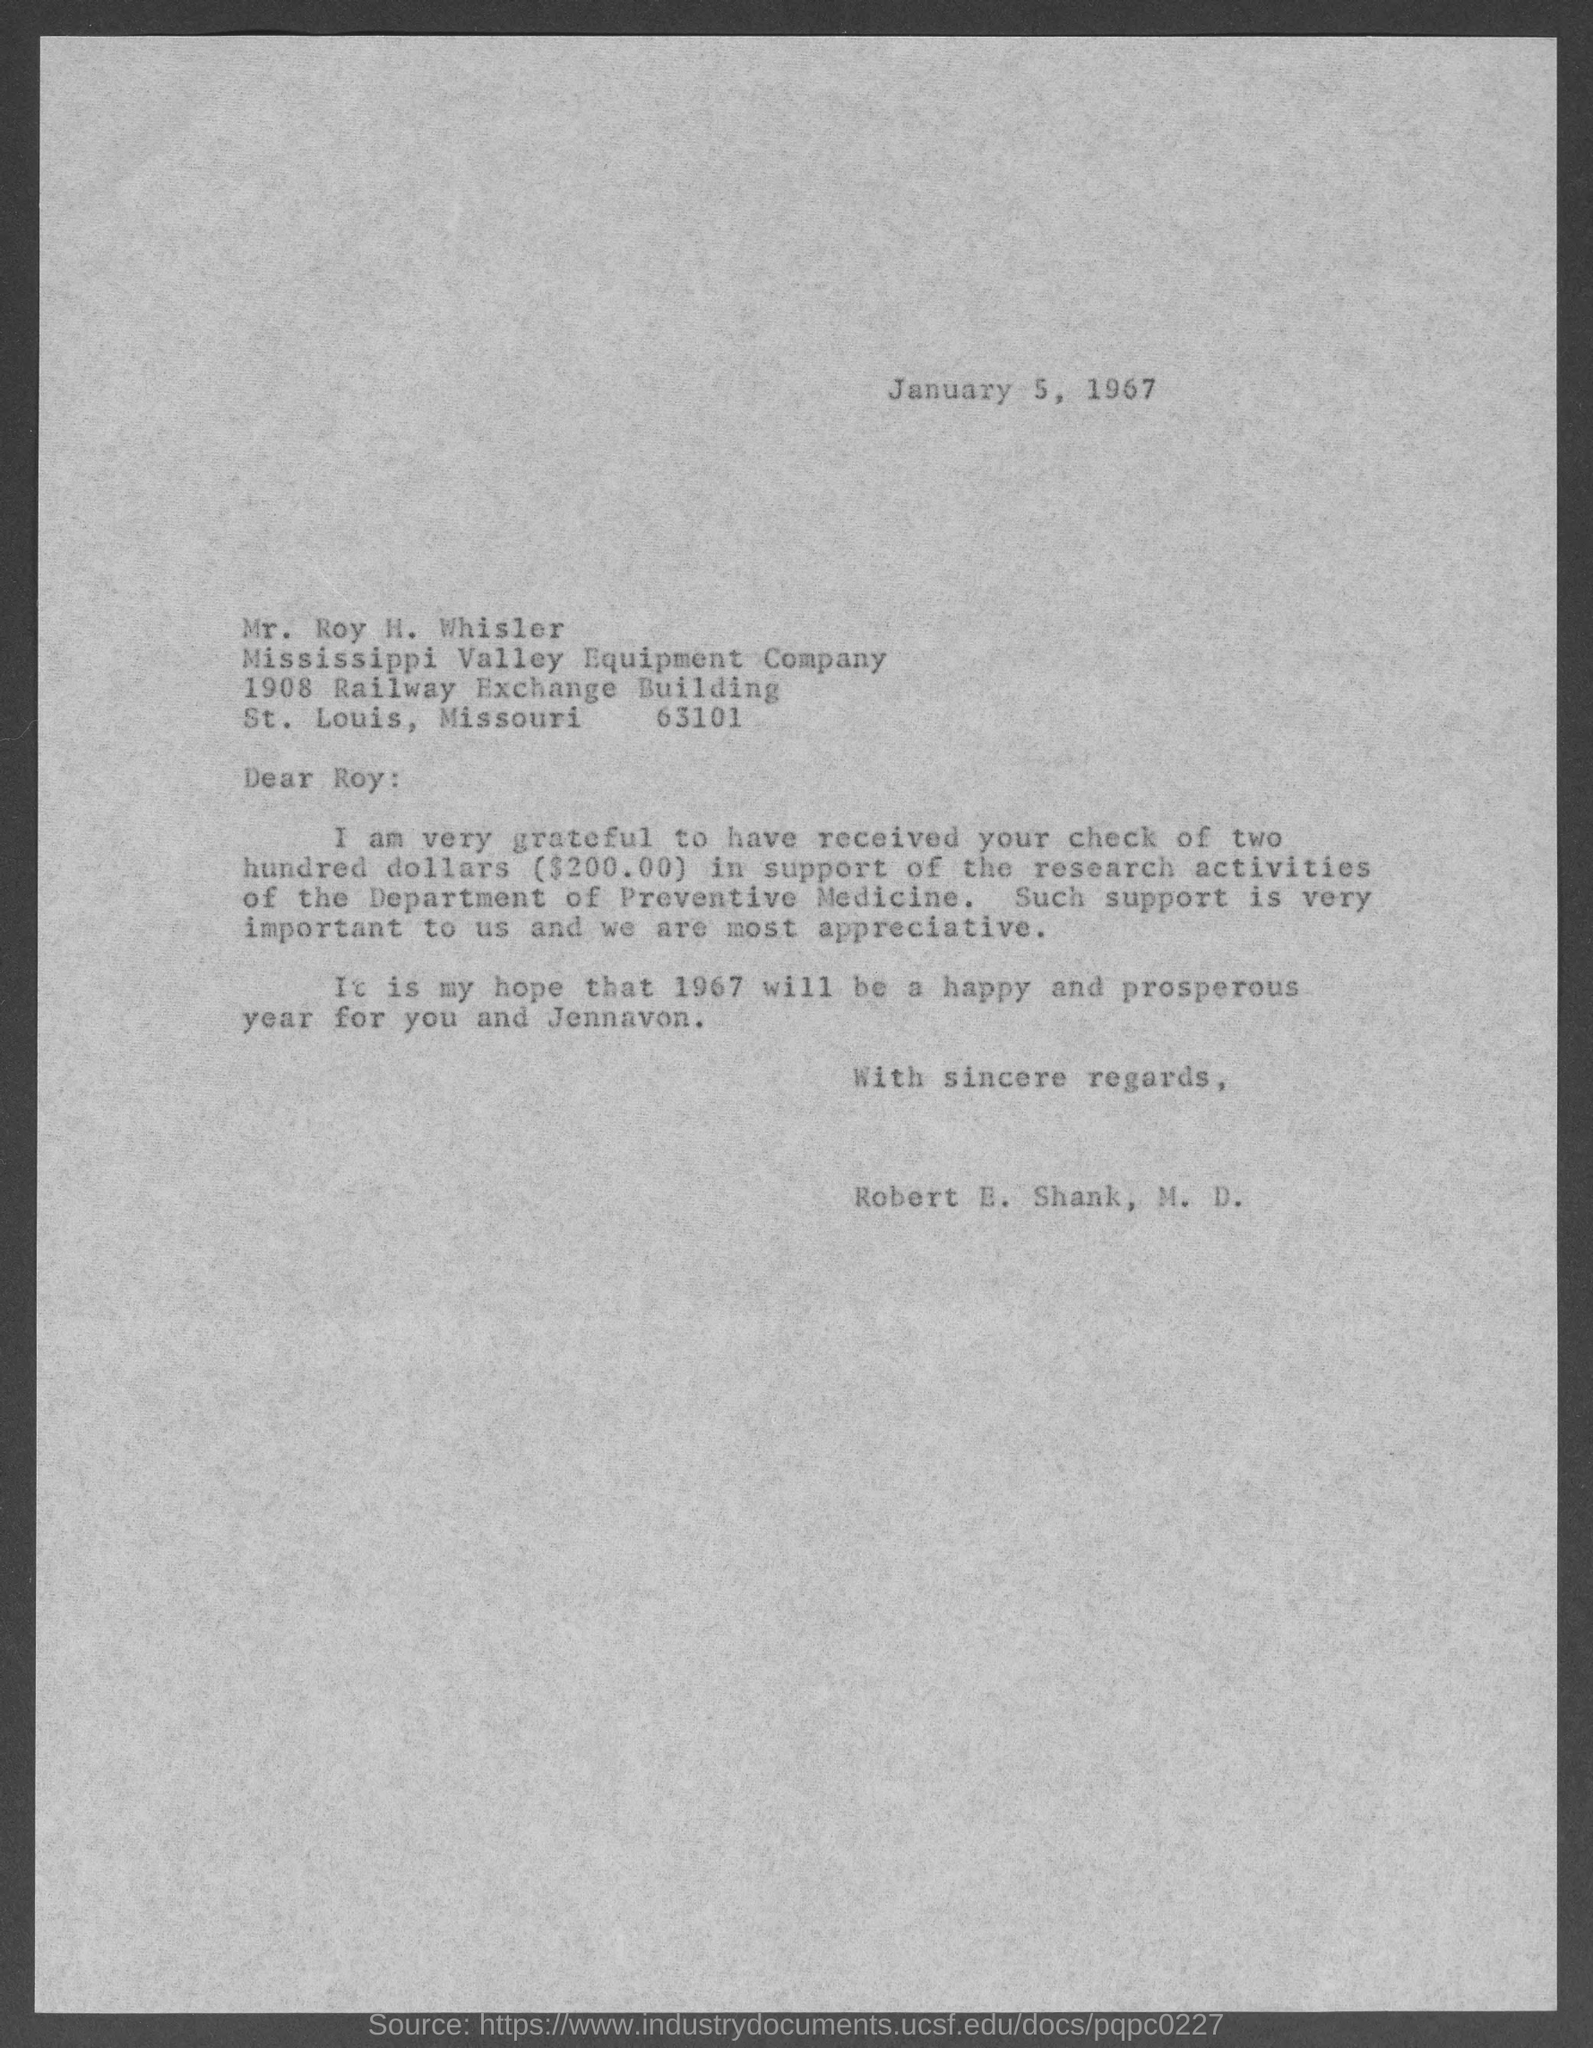Outline some significant characteristics in this image. This letter was written on January 5, 1967. The cheque is for $200.00. The author of this letter is Robert E. Shank, M.D. The recipient of the letter is Mr. Roy H. Whisler. Mr. Roy H. Whisler is affiliated with the Mississippi Valley Equipment Company. 